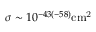<formula> <loc_0><loc_0><loc_500><loc_500>\sigma \sim 1 0 ^ { - 4 3 ( - 5 8 ) } { c m } ^ { 2 }</formula> 